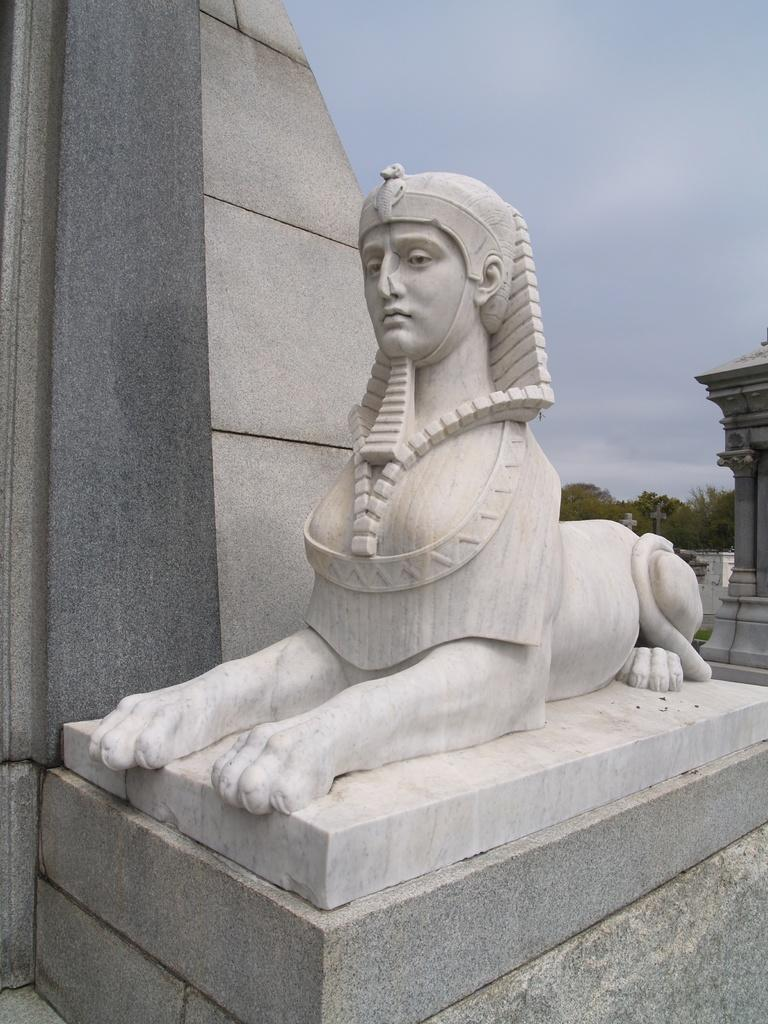What is the main subject in the foreground of the image? There is a statue in the foreground of the image. What type of natural elements can be seen in the background of the image? There are trees in the background of the image. Can you describe the sky in the image? The sky is visible at the top of the image. What type of tent is being offered to the statue in the image? There is no tent present in the image, and the statue is not being offered anything. 